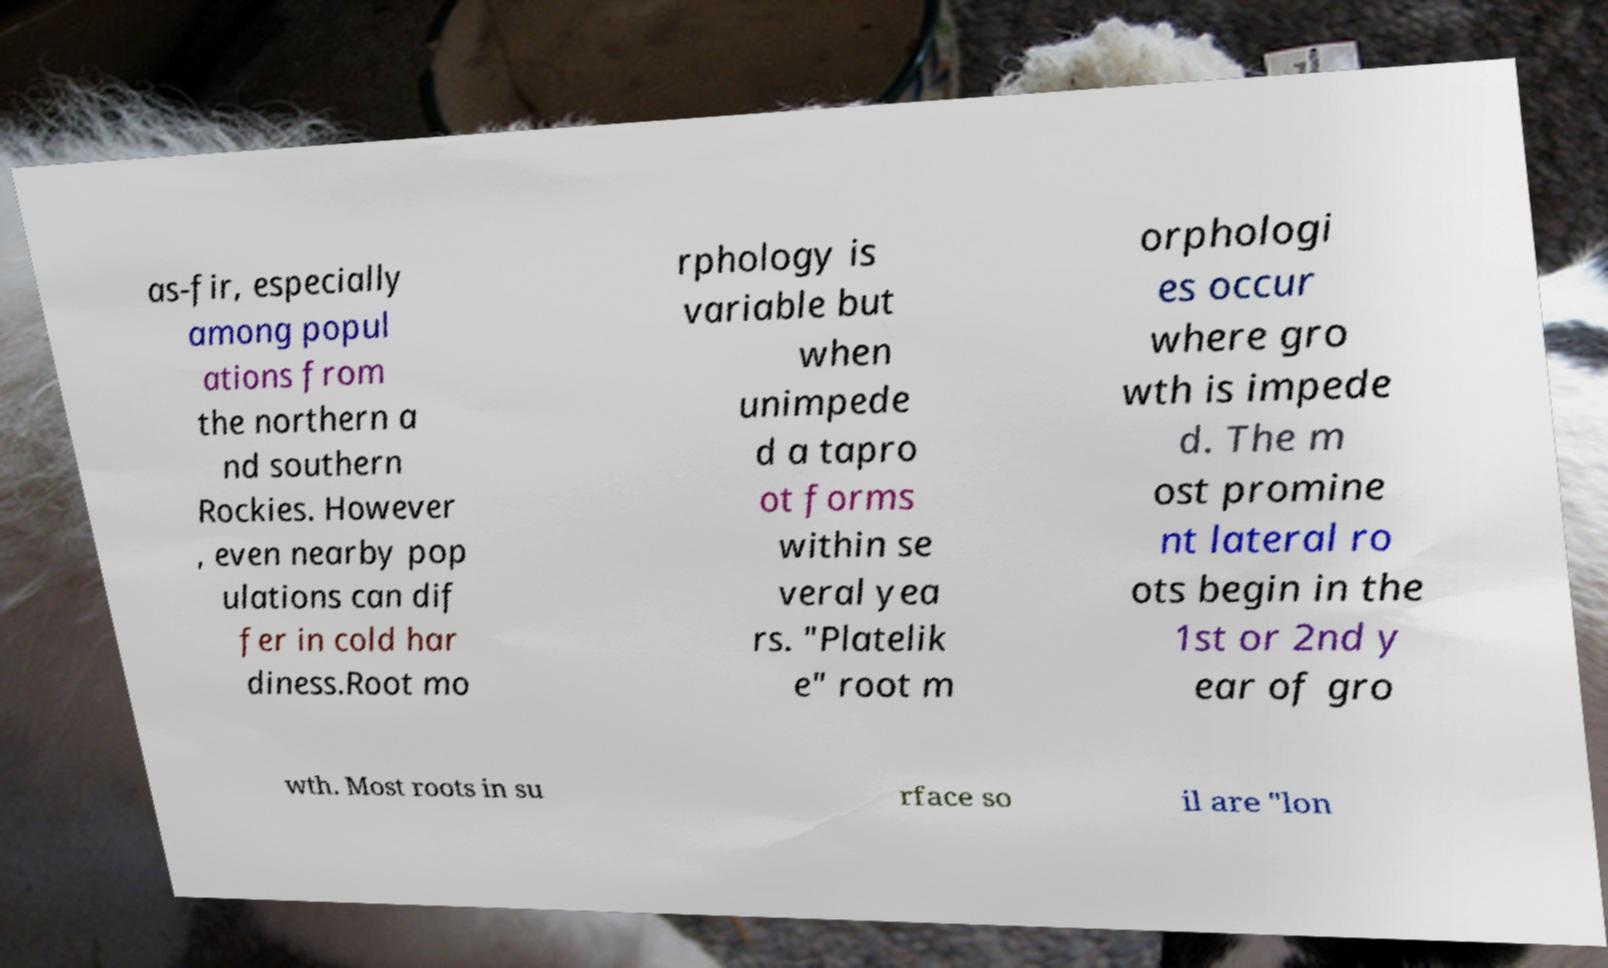There's text embedded in this image that I need extracted. Can you transcribe it verbatim? as-fir, especially among popul ations from the northern a nd southern Rockies. However , even nearby pop ulations can dif fer in cold har diness.Root mo rphology is variable but when unimpede d a tapro ot forms within se veral yea rs. "Platelik e" root m orphologi es occur where gro wth is impede d. The m ost promine nt lateral ro ots begin in the 1st or 2nd y ear of gro wth. Most roots in su rface so il are "lon 